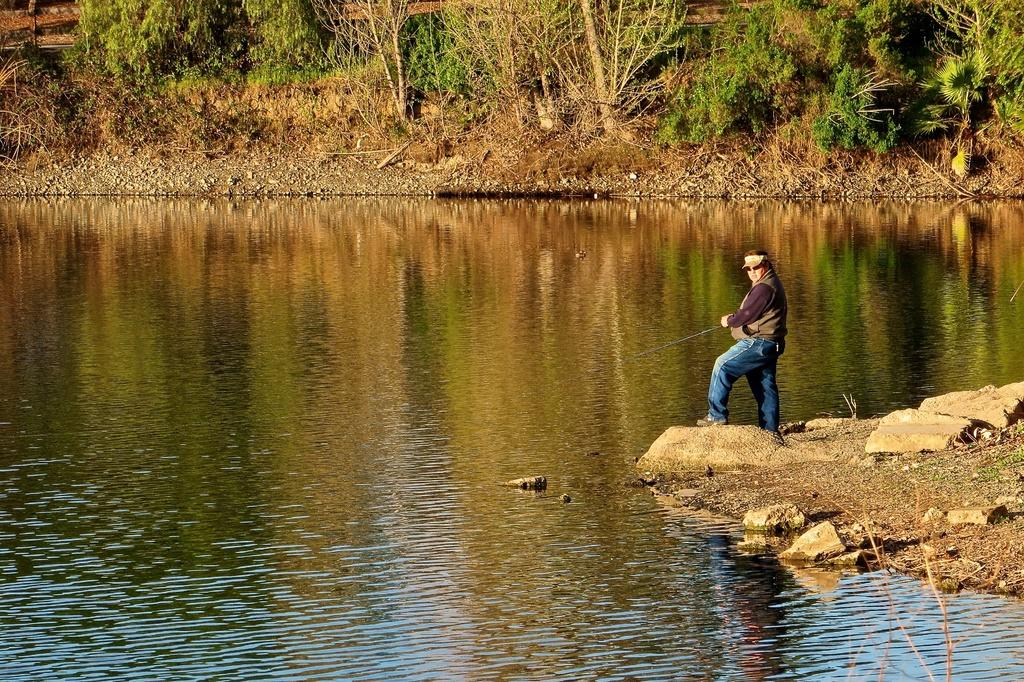Who is present in the image? There is a man in the image. What is the man doing in the image? The man is holding a fishing rod and fishing. What can be seen in the background of the image? There are trees in the background of the image. What is the primary feature of the ground in the image? There are stones on the ground. What is the location of the man in the image? The man is located near a water body, as he is fishing. How many cats are sitting on the cherry tree in the image? There are no cats or cherry trees present in the image. What type of cellar can be seen in the image? There is no cellar present in the image. 